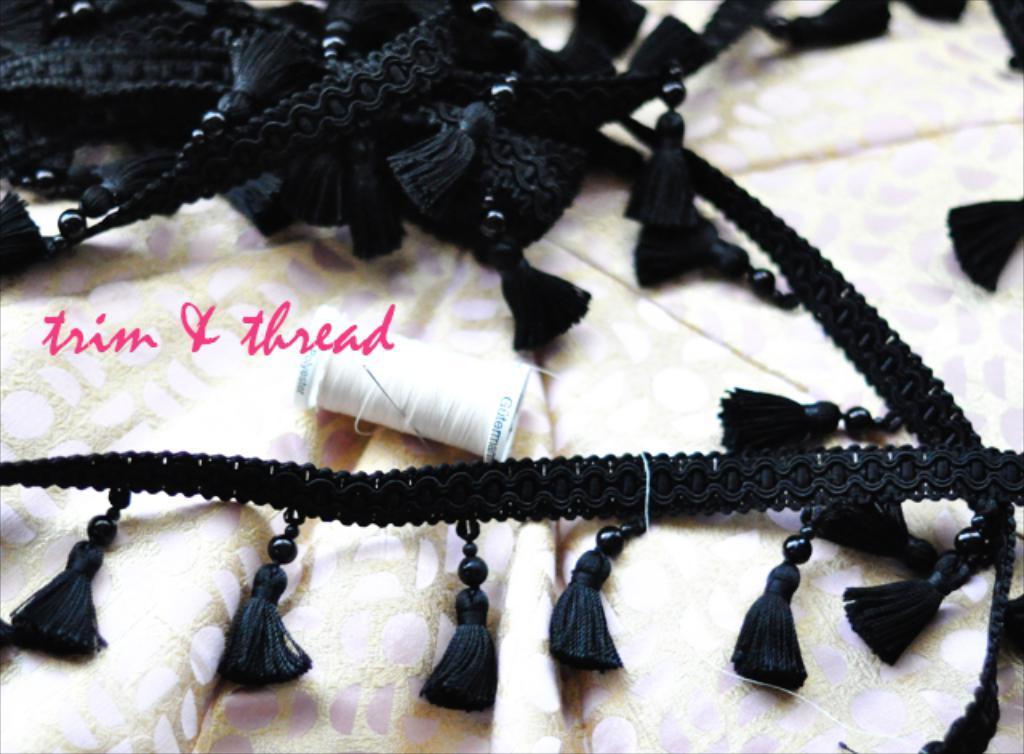In one or two sentences, can you explain what this image depicts? In this image I can see a black colored cloth, a thread bundle and a needle to it on the cream and pink colored cloth. I can see something is written on the image. 